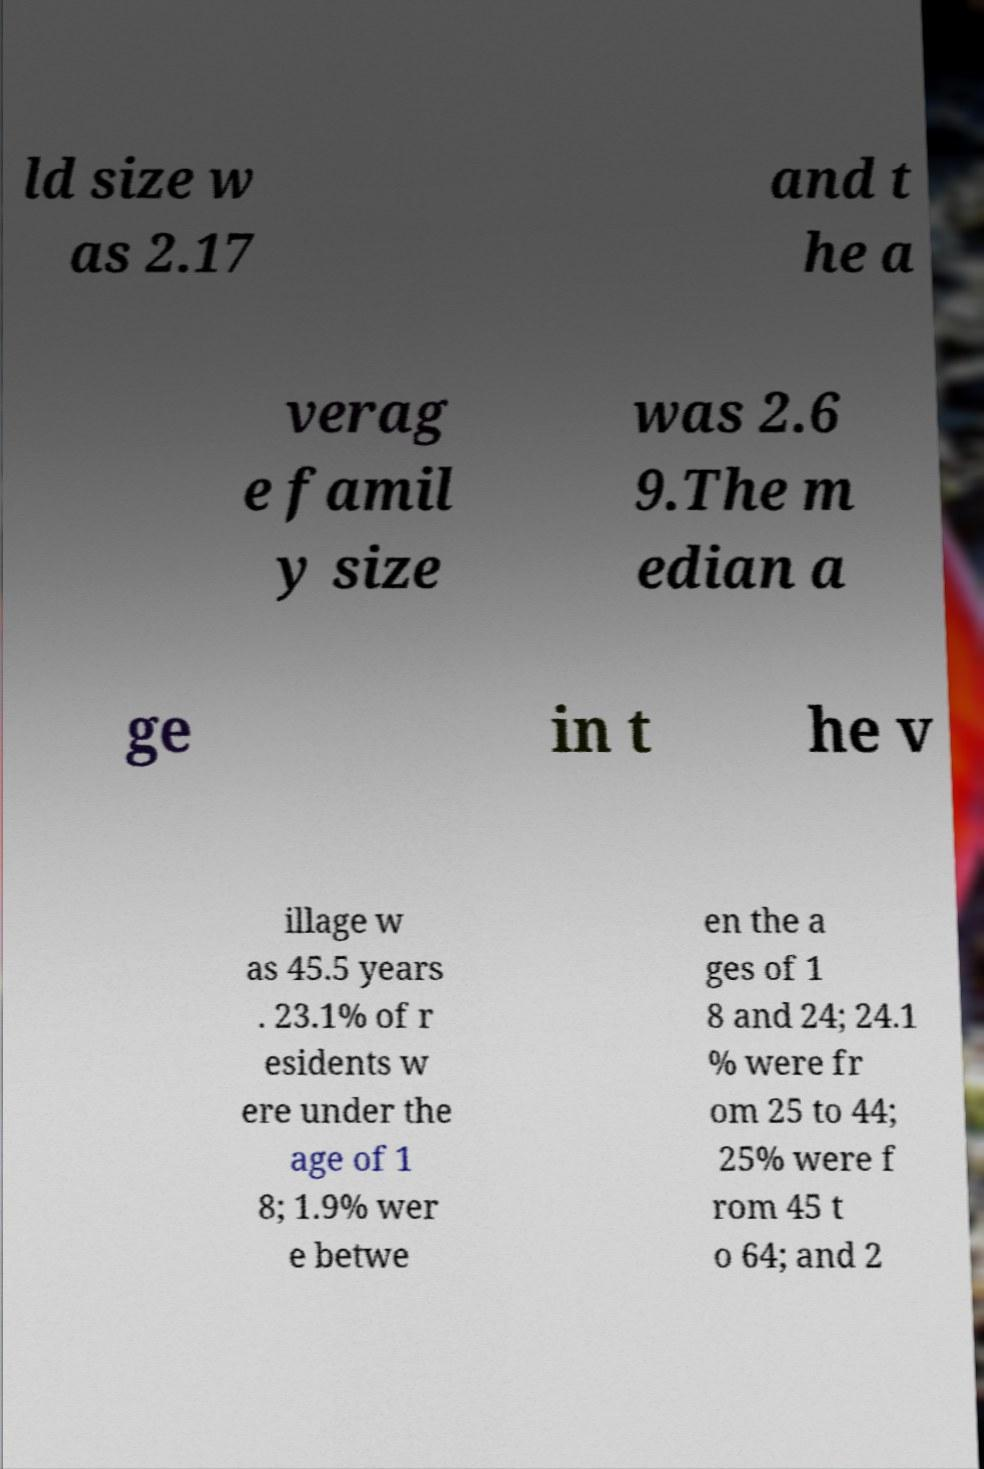What messages or text are displayed in this image? I need them in a readable, typed format. ld size w as 2.17 and t he a verag e famil y size was 2.6 9.The m edian a ge in t he v illage w as 45.5 years . 23.1% of r esidents w ere under the age of 1 8; 1.9% wer e betwe en the a ges of 1 8 and 24; 24.1 % were fr om 25 to 44; 25% were f rom 45 t o 64; and 2 